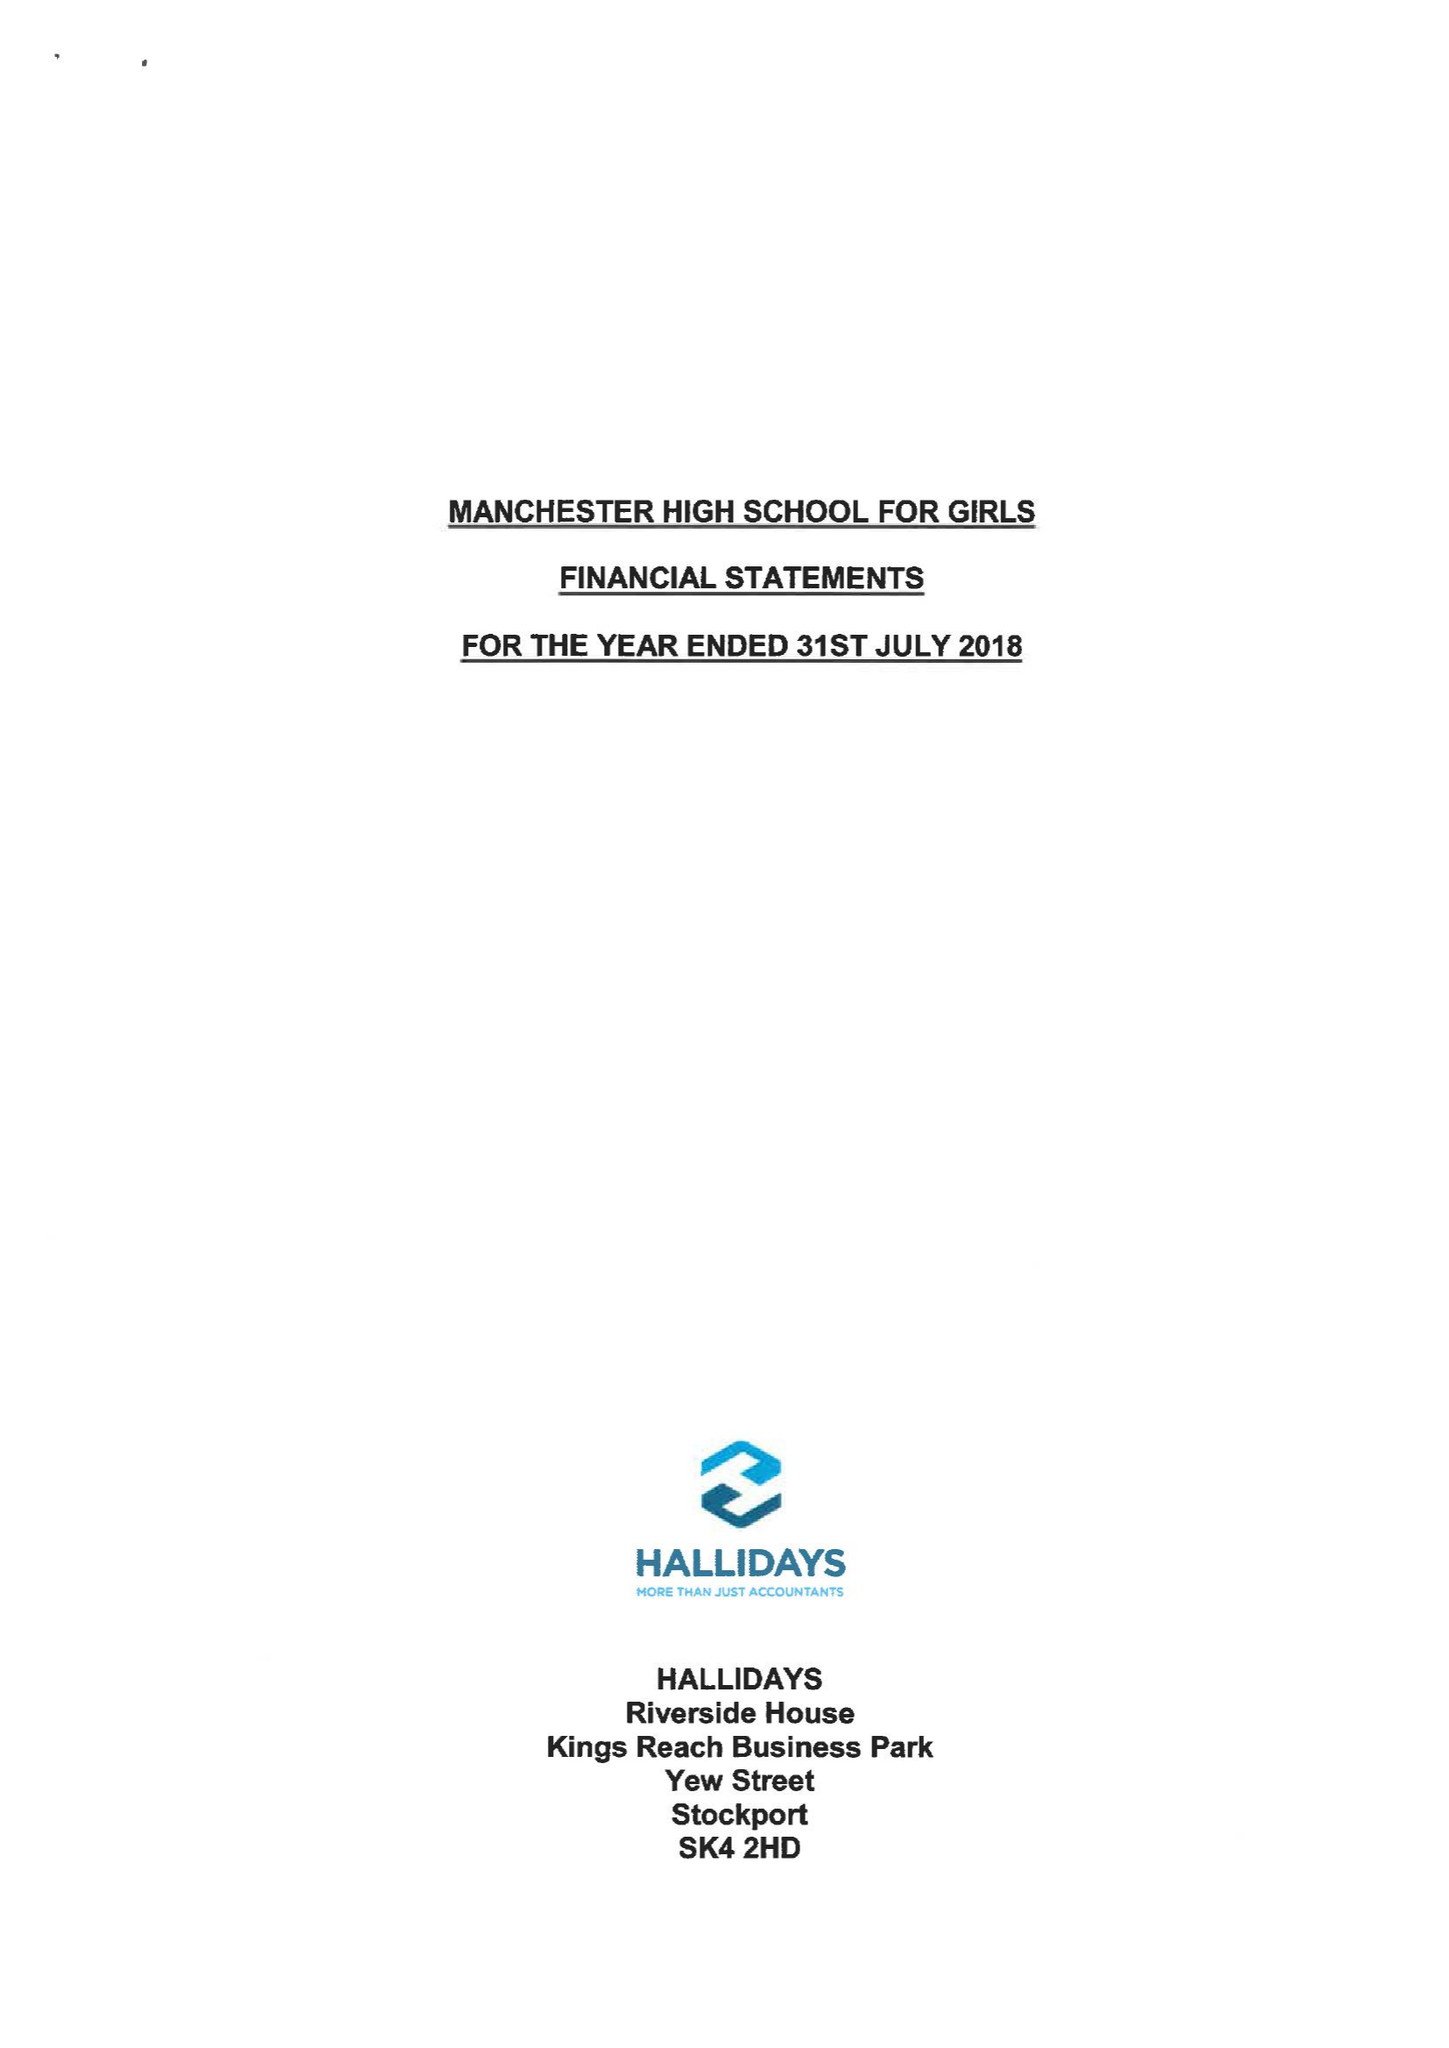What is the value for the address__postcode?
Answer the question using a single word or phrase. M14 6HS 